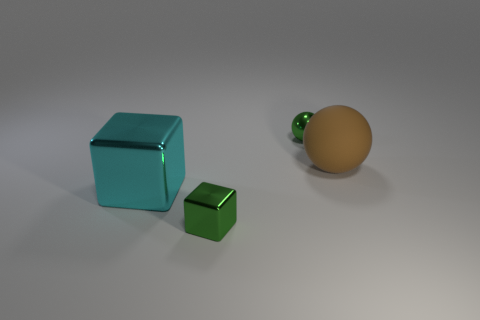Is there any other thing that is the same material as the big brown thing?
Give a very brief answer. No. There is a big thing right of the green shiny block; what material is it?
Keep it short and to the point. Rubber. What number of other objects are there of the same size as the rubber sphere?
Ensure brevity in your answer.  1. There is a green ball; does it have the same size as the green metallic thing in front of the matte sphere?
Offer a terse response. Yes. The green thing right of the tiny green object that is on the left side of the ball that is on the left side of the large matte ball is what shape?
Offer a terse response. Sphere. Are there fewer large brown rubber spheres than big gray spheres?
Make the answer very short. No. There is a small green metallic block; are there any cyan metal cubes to the left of it?
Provide a succinct answer. Yes. There is a object that is on the right side of the cyan metallic block and in front of the brown object; what is its shape?
Your response must be concise. Cube. Are there any green metal things that have the same shape as the large brown rubber thing?
Your answer should be very brief. Yes. There is a green shiny object that is behind the small shiny cube; does it have the same size as the brown sphere behind the green shiny block?
Offer a terse response. No. 